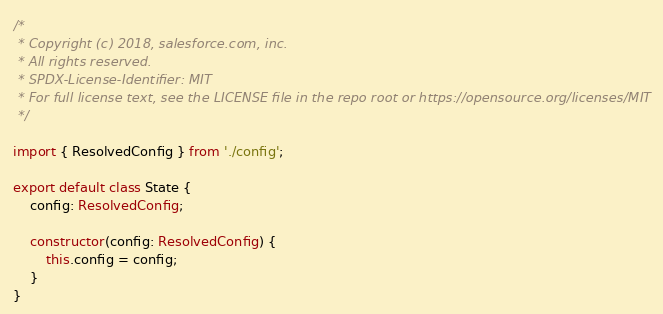Convert code to text. <code><loc_0><loc_0><loc_500><loc_500><_TypeScript_>/*
 * Copyright (c) 2018, salesforce.com, inc.
 * All rights reserved.
 * SPDX-License-Identifier: MIT
 * For full license text, see the LICENSE file in the repo root or https://opensource.org/licenses/MIT
 */

import { ResolvedConfig } from './config';

export default class State {
    config: ResolvedConfig;

    constructor(config: ResolvedConfig) {
        this.config = config;
    }
}
</code> 